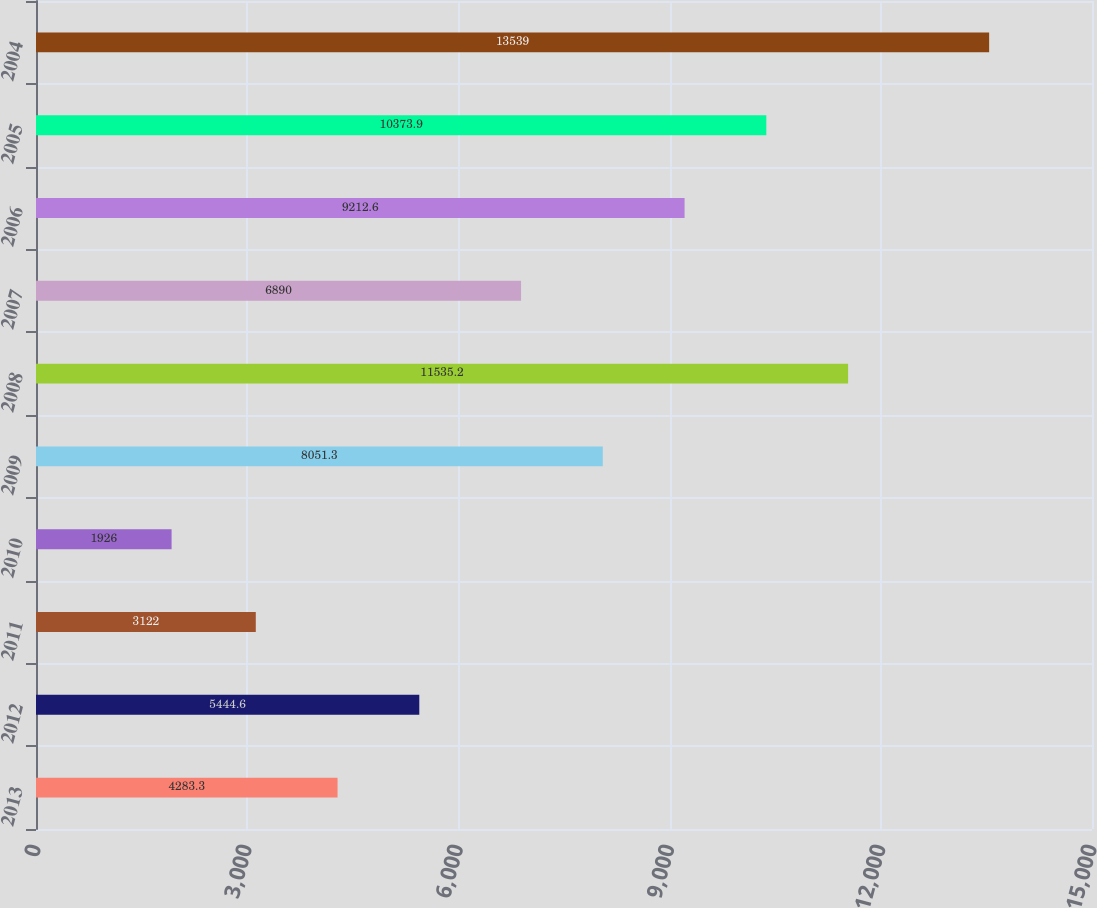Convert chart to OTSL. <chart><loc_0><loc_0><loc_500><loc_500><bar_chart><fcel>2013<fcel>2012<fcel>2011<fcel>2010<fcel>2009<fcel>2008<fcel>2007<fcel>2006<fcel>2005<fcel>2004<nl><fcel>4283.3<fcel>5444.6<fcel>3122<fcel>1926<fcel>8051.3<fcel>11535.2<fcel>6890<fcel>9212.6<fcel>10373.9<fcel>13539<nl></chart> 